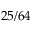<formula> <loc_0><loc_0><loc_500><loc_500>2 5 / 6 4</formula> 